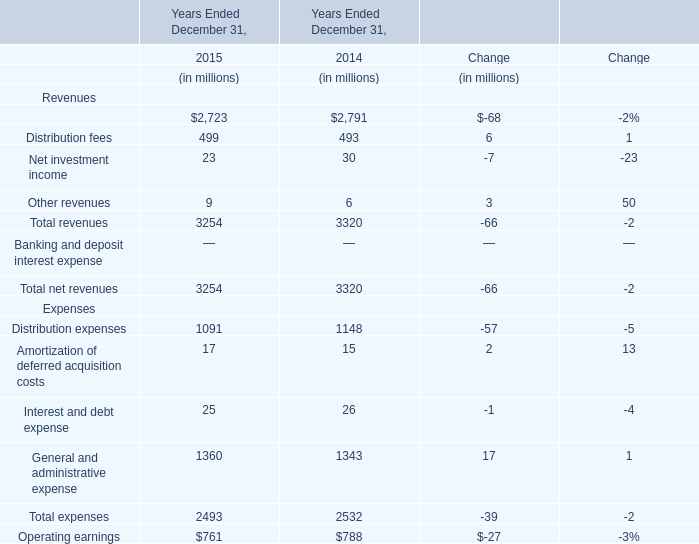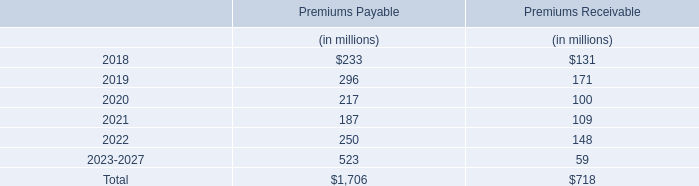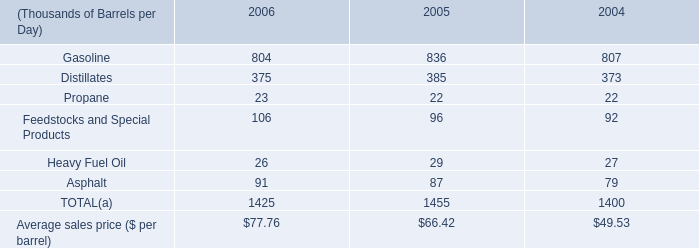What's the average of Management and financial advice fees in 2015 and 2014? (in million) 
Computations: ((2723 + 2791) / 2)
Answer: 2757.0. 